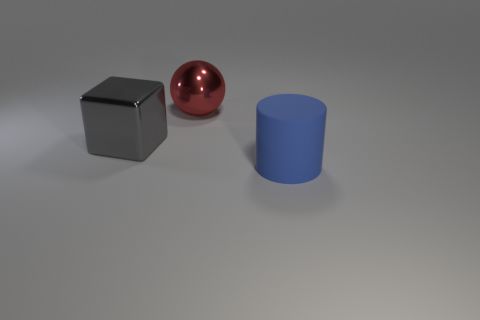What number of other objects are the same size as the shiny sphere?
Make the answer very short. 2. Do the blue thing that is in front of the large red thing and the large thing that is behind the large gray shiny thing have the same material?
Offer a terse response. No. How many gray things are behind the large red ball?
Offer a terse response. 0. How many red objects are either cylinders or spheres?
Offer a very short reply. 1. There is a gray block that is the same size as the metal sphere; what is it made of?
Your answer should be very brief. Metal. The big thing that is both in front of the ball and on the right side of the big cube has what shape?
Give a very brief answer. Cylinder. There is a sphere that is the same size as the cylinder; what is its color?
Your answer should be compact. Red. There is a red sphere behind the gray shiny cube; is its size the same as the metal object that is left of the large metallic sphere?
Offer a terse response. Yes. There is a metal thing in front of the big thing that is behind the big object to the left of the red metal thing; how big is it?
Your answer should be compact. Large. There is a metal object to the left of the big object that is behind the metal block; what shape is it?
Your answer should be very brief. Cube. 